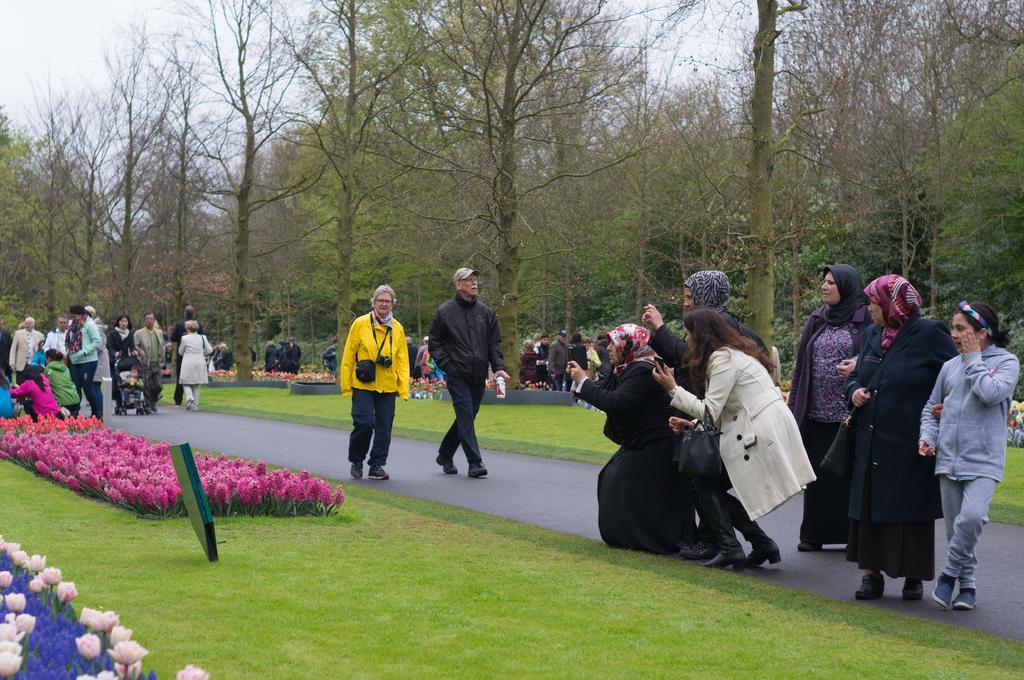Describe this image in one or two sentences. In this image there are group of persons standing and walking. In the front there's grass on the ground and there are flowers on the ground. In the center there are persons standing and clicking a photo. In the background there are trees and the sky is cloudy. 